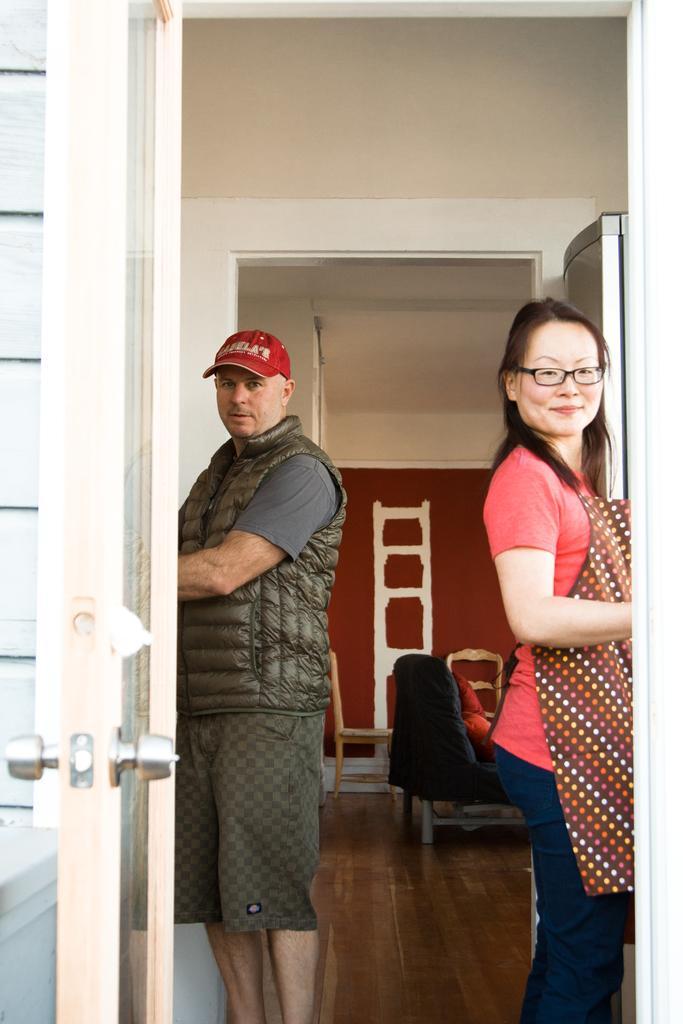Please provide a concise description of this image. Here a man is on the left and a woman is on the right. This is a door. In the background we can see a chair and wall. 